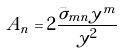Convert formula to latex. <formula><loc_0><loc_0><loc_500><loc_500>A _ { n } = 2 \frac { \bar { \sigma } _ { m n } y ^ { m } } { y ^ { 2 } }</formula> 